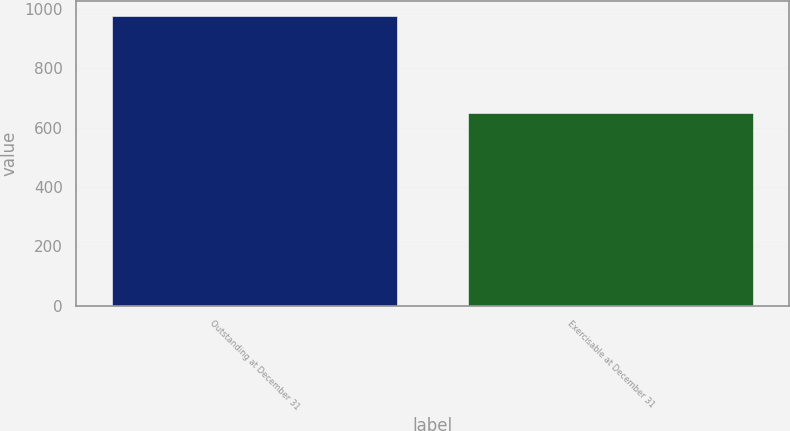Convert chart. <chart><loc_0><loc_0><loc_500><loc_500><bar_chart><fcel>Outstanding at December 31<fcel>Exercisable at December 31<nl><fcel>977.9<fcel>650.1<nl></chart> 